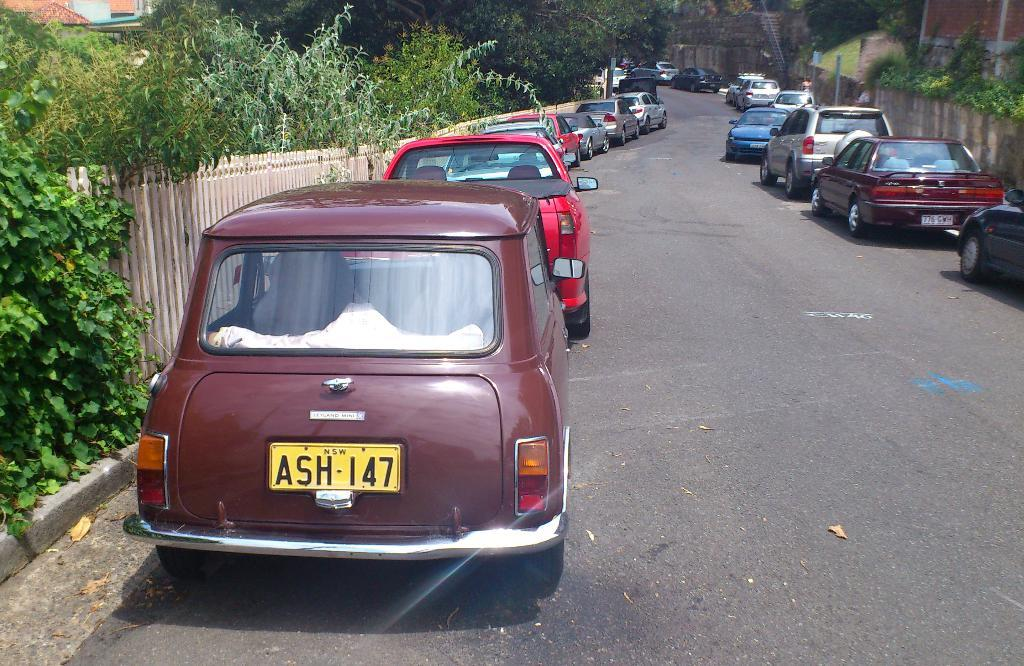What types of objects are present on the road in the image? There are vehicles on the road in the image. What can be seen near the vehicles in the image? There is a railing, buildings, trees, plants, and a road in the image. Are there any people visible in the image? Yes, there are people in the image. What other structures can be seen in the image? There is a pole in the image. What else is present in the image besides the structures and people? There are objects in the image. How many chairs can be seen in the image? There are no chairs present in the image. What type of box is visible in the image? There is no box present in the image. 